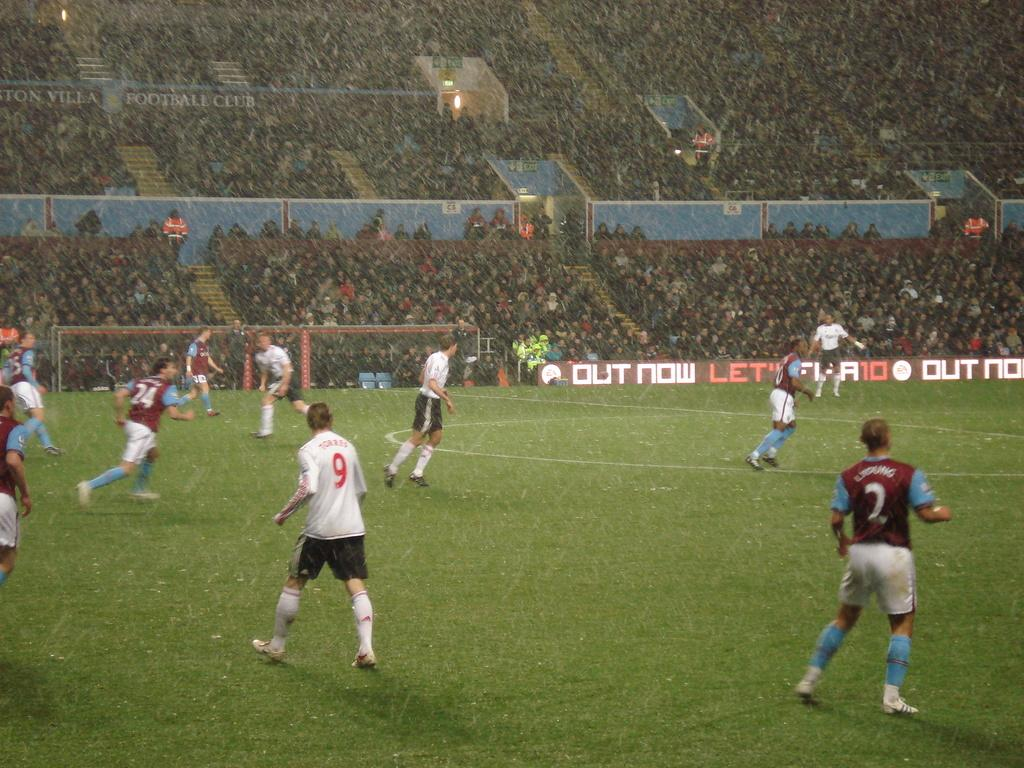<image>
Give a short and clear explanation of the subsequent image. A soccer field with players 9 and 2 standing toward the camera 